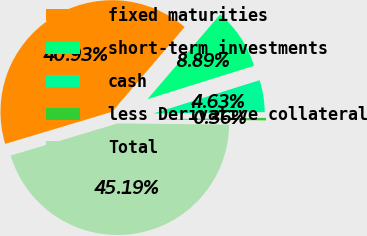Convert chart. <chart><loc_0><loc_0><loc_500><loc_500><pie_chart><fcel>fixed maturities<fcel>short-term investments<fcel>cash<fcel>less Derivative collateral<fcel>Total<nl><fcel>40.93%<fcel>8.89%<fcel>4.63%<fcel>0.36%<fcel>45.19%<nl></chart> 